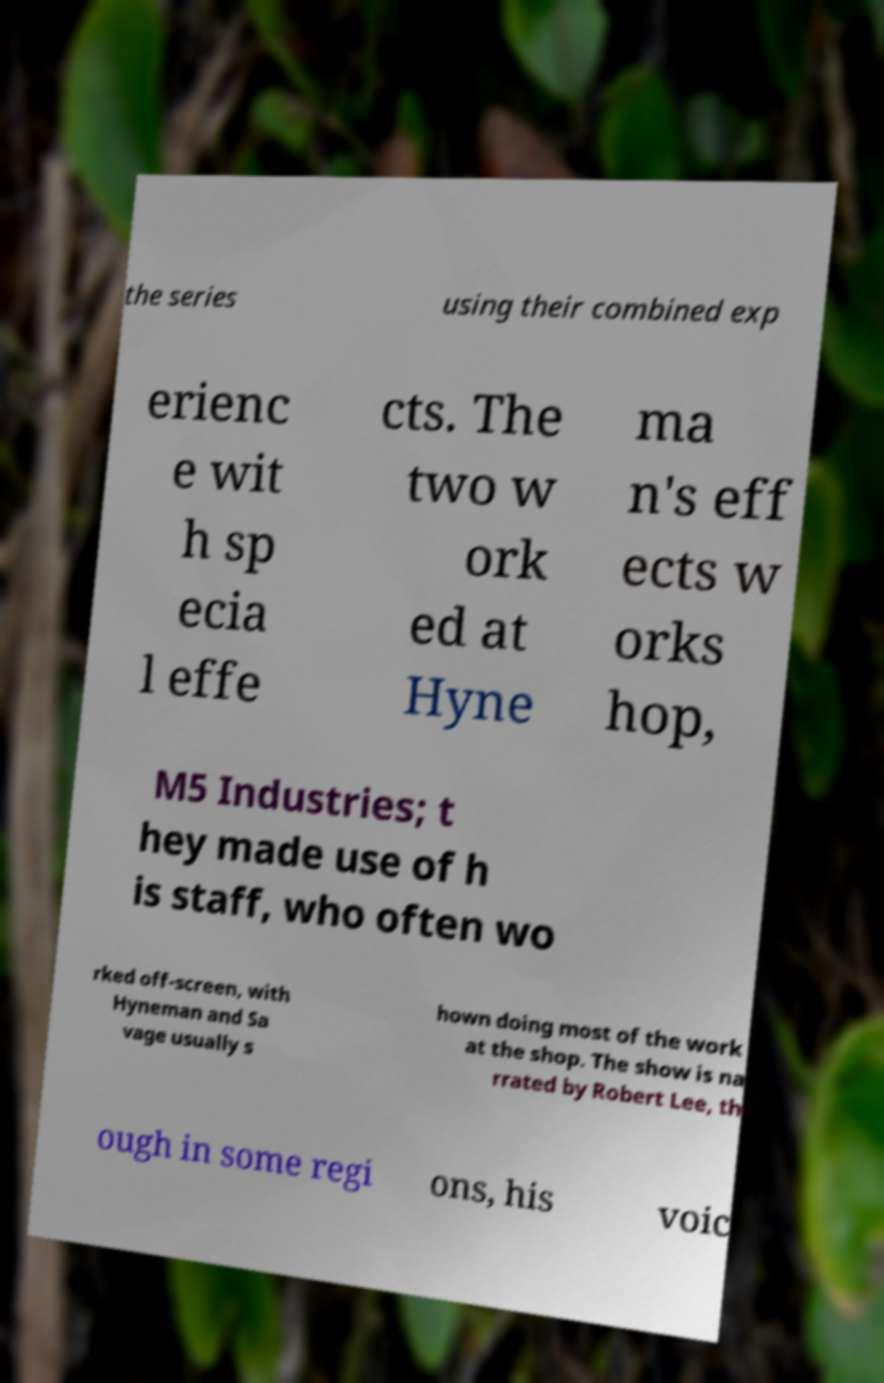Please read and relay the text visible in this image. What does it say? the series using their combined exp erienc e wit h sp ecia l effe cts. The two w ork ed at Hyne ma n's eff ects w orks hop, M5 Industries; t hey made use of h is staff, who often wo rked off-screen, with Hyneman and Sa vage usually s hown doing most of the work at the shop. The show is na rrated by Robert Lee, th ough in some regi ons, his voic 